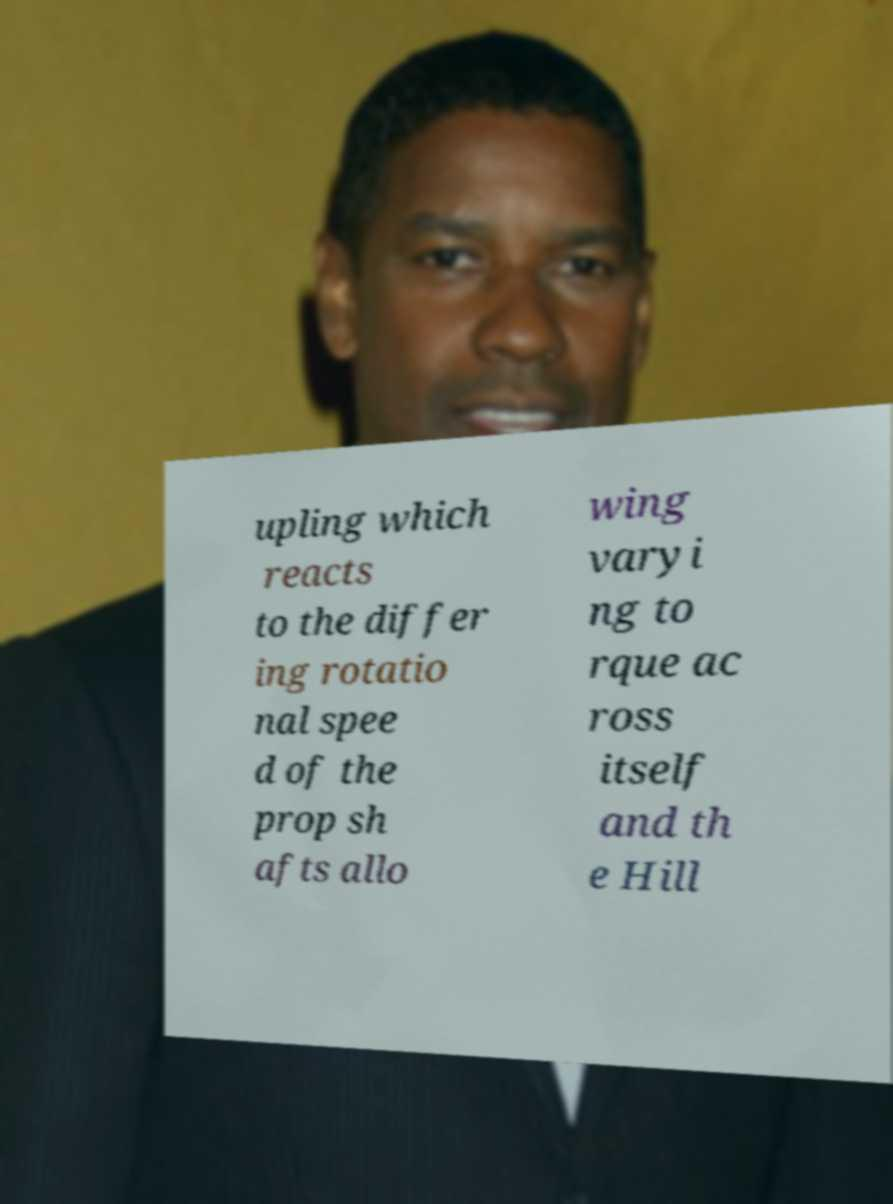There's text embedded in this image that I need extracted. Can you transcribe it verbatim? upling which reacts to the differ ing rotatio nal spee d of the prop sh afts allo wing varyi ng to rque ac ross itself and th e Hill 